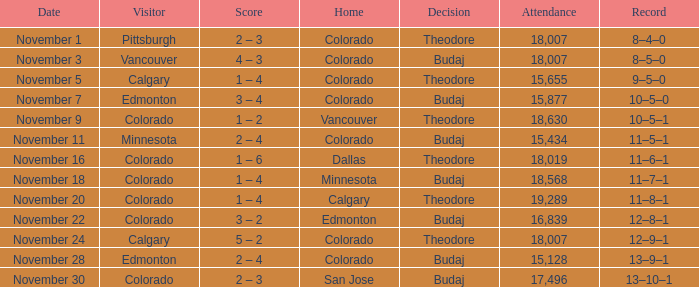Who was the Home Team while Calgary was visiting while having an Attendance above 15,655? Colorado. 